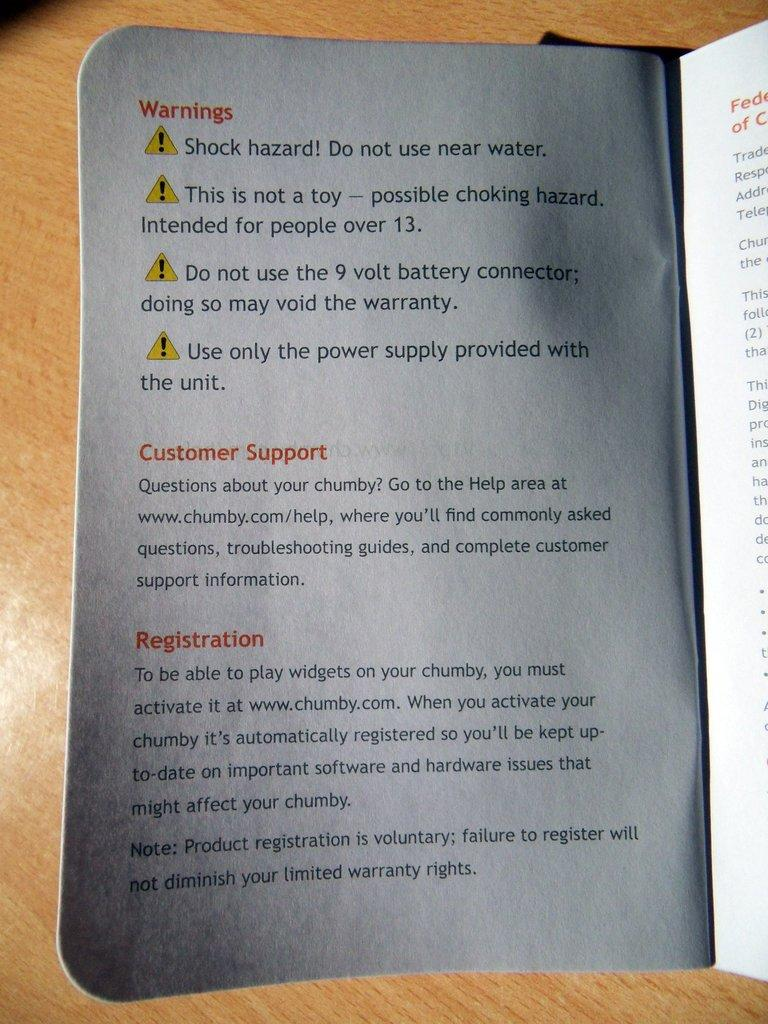<image>
Render a clear and concise summary of the photo. a WARNINGS pamphlet with various things to watch out for 